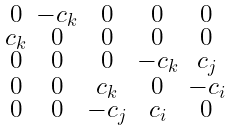Convert formula to latex. <formula><loc_0><loc_0><loc_500><loc_500>\begin{smallmatrix} 0 & - c _ { k } & 0 & 0 & 0 \\ c _ { k } & 0 & 0 & 0 & 0 \\ 0 & 0 & 0 & - c _ { k } & c _ { j } \\ 0 & 0 & c _ { k } & 0 & - c _ { i } \\ 0 & 0 & - c _ { j } & c _ { i } & 0 \end{smallmatrix}</formula> 